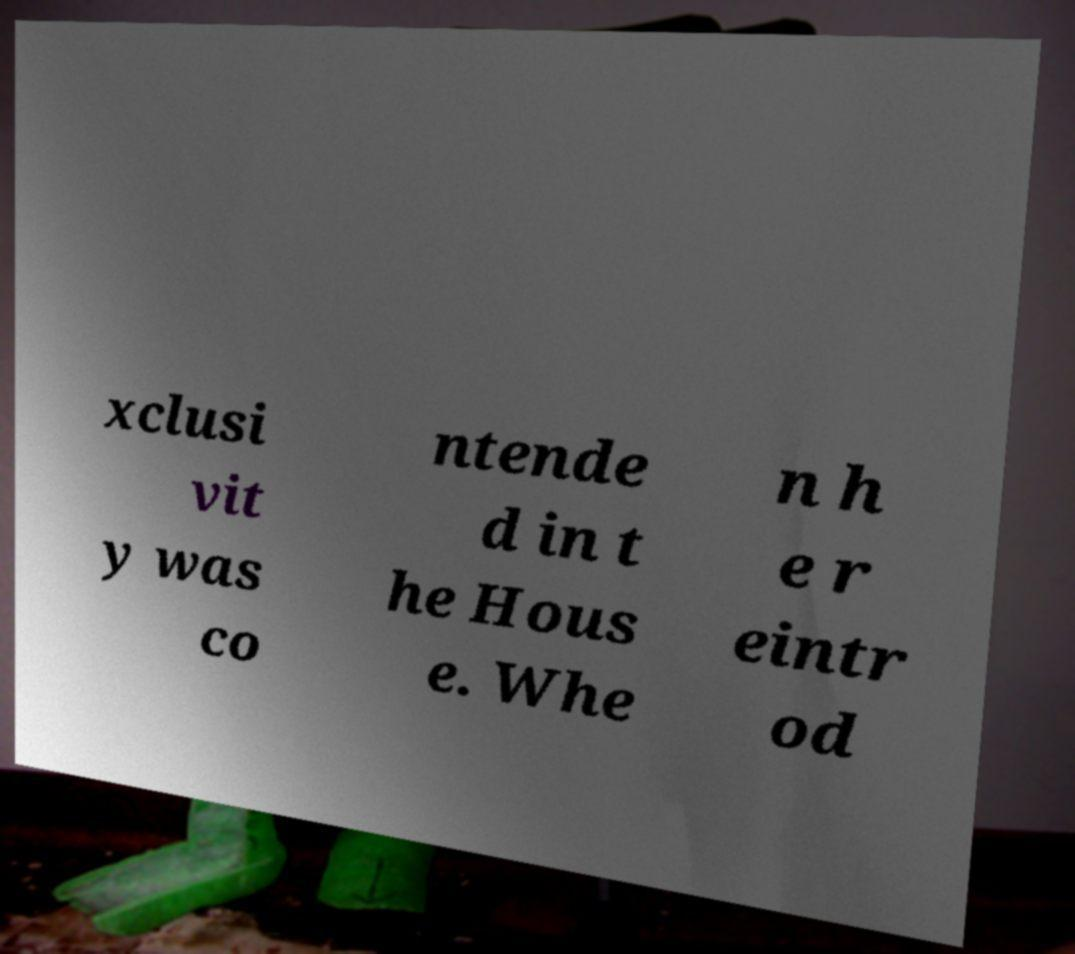Please identify and transcribe the text found in this image. xclusi vit y was co ntende d in t he Hous e. Whe n h e r eintr od 